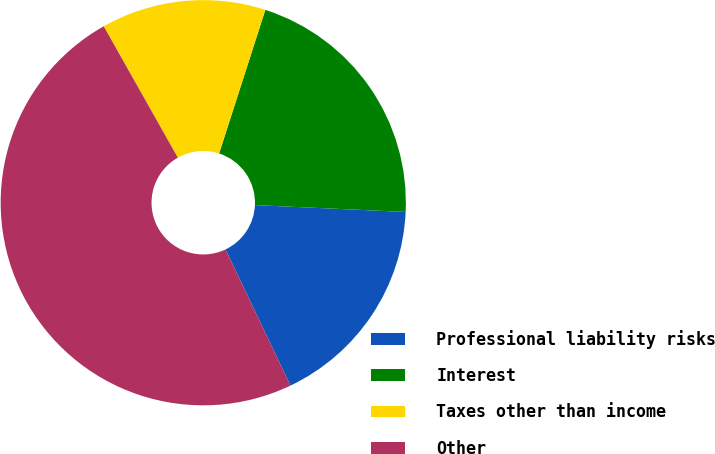<chart> <loc_0><loc_0><loc_500><loc_500><pie_chart><fcel>Professional liability risks<fcel>Interest<fcel>Taxes other than income<fcel>Other<nl><fcel>17.19%<fcel>20.77%<fcel>13.13%<fcel>48.91%<nl></chart> 